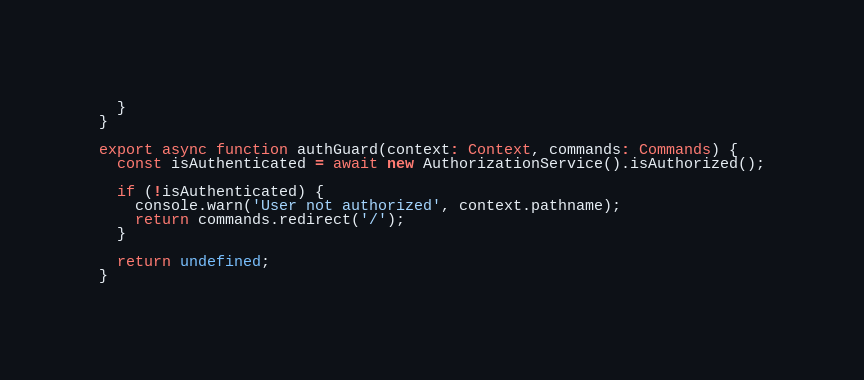Convert code to text. <code><loc_0><loc_0><loc_500><loc_500><_TypeScript_>  }
}

export async function authGuard(context: Context, commands: Commands) {
  const isAuthenticated = await new AuthorizationService().isAuthorized();

  if (!isAuthenticated) {
    console.warn('User not authorized', context.pathname);
    return commands.redirect('/');
  }

  return undefined;
}
</code> 